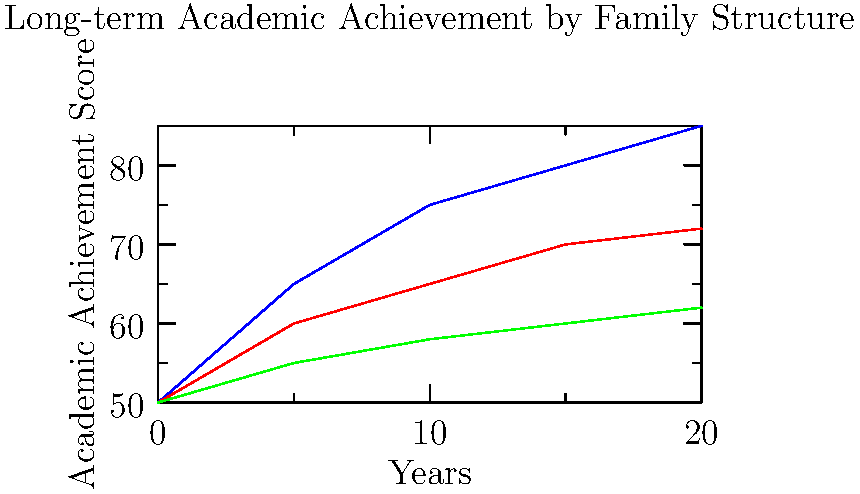Based on the line graph showing long-term academic achievement by family structure, what conclusions can be drawn about the impact of different family structures on children's academic performance over time? How does this data relate to the potential benefits of youth academies for children from various family backgrounds? To answer this question, let's analyze the graph step-by-step:

1. The graph shows academic achievement scores for children from three different family structures over 20 years: two-parent families, single-parent families, and foster care.

2. Two-parent families (blue line):
   - Start at 50 points
   - Show the steepest increase, reaching 85 points after 20 years
   - Demonstrate the highest overall academic achievement

3. Single-parent families (red line):
   - Also start at 50 points
   - Show a moderate increase, reaching 72 points after 20 years
   - Consistently perform better than foster care, but lower than two-parent families

4. Foster care (green line):
   - Start at 50 points like the others
   - Show the slowest increase, reaching only 62 points after 20 years
   - Consistently perform the lowest among the three groups

5. Conclusions:
   - Children from two-parent families tend to have the highest academic achievement over time.
   - Single-parent families show better outcomes than foster care, but not as high as two-parent families.
   - All family structures show improvement over time, but at different rates.

6. Relation to youth academies:
   - Youth academies can potentially help bridge the gap between different family structures by providing additional support and resources.
   - For single-parent families, youth academies may offer valuable mentorship and guidance that could help improve children's academic outcomes.
   - Children in foster care might benefit significantly from the stability and consistent support provided by youth academies.
   - Even children from two-parent families could further enhance their achievement through youth academy programs.

7. The persona of a single mother who attributes her child's success to a youth academy aligns with this data:
   - The graph shows that single-parent families face more challenges in achieving the same academic outcomes as two-parent families.
   - However, with additional support (like that provided by youth academies), children from single-parent families can potentially narrow this gap and achieve better outcomes than they might otherwise.

In conclusion, while family structure appears to influence academic achievement, interventions like youth academies can play a crucial role in supporting children's academic growth, especially for those from single-parent families or foster care situations.
Answer: Family structure impacts academic achievement, with two-parent families showing the highest scores, followed by single-parent families, then foster care. Youth academies can potentially help narrow these gaps by providing additional support and resources to children from all family backgrounds. 